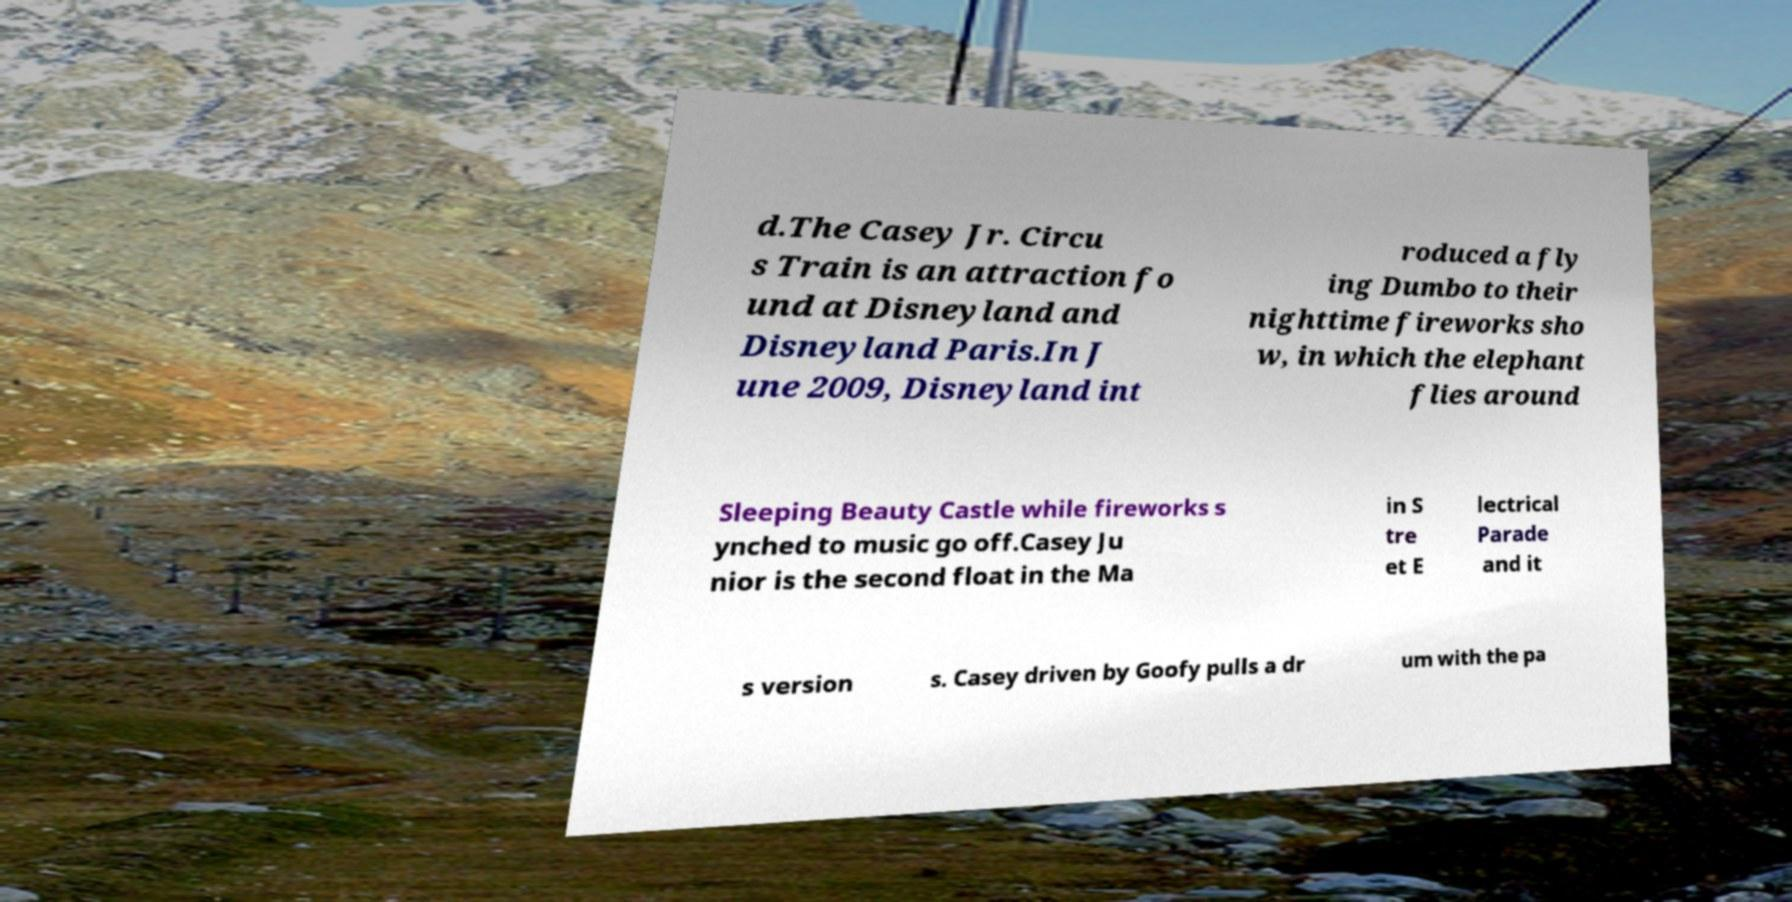What messages or text are displayed in this image? I need them in a readable, typed format. d.The Casey Jr. Circu s Train is an attraction fo und at Disneyland and Disneyland Paris.In J une 2009, Disneyland int roduced a fly ing Dumbo to their nighttime fireworks sho w, in which the elephant flies around Sleeping Beauty Castle while fireworks s ynched to music go off.Casey Ju nior is the second float in the Ma in S tre et E lectrical Parade and it s version s. Casey driven by Goofy pulls a dr um with the pa 